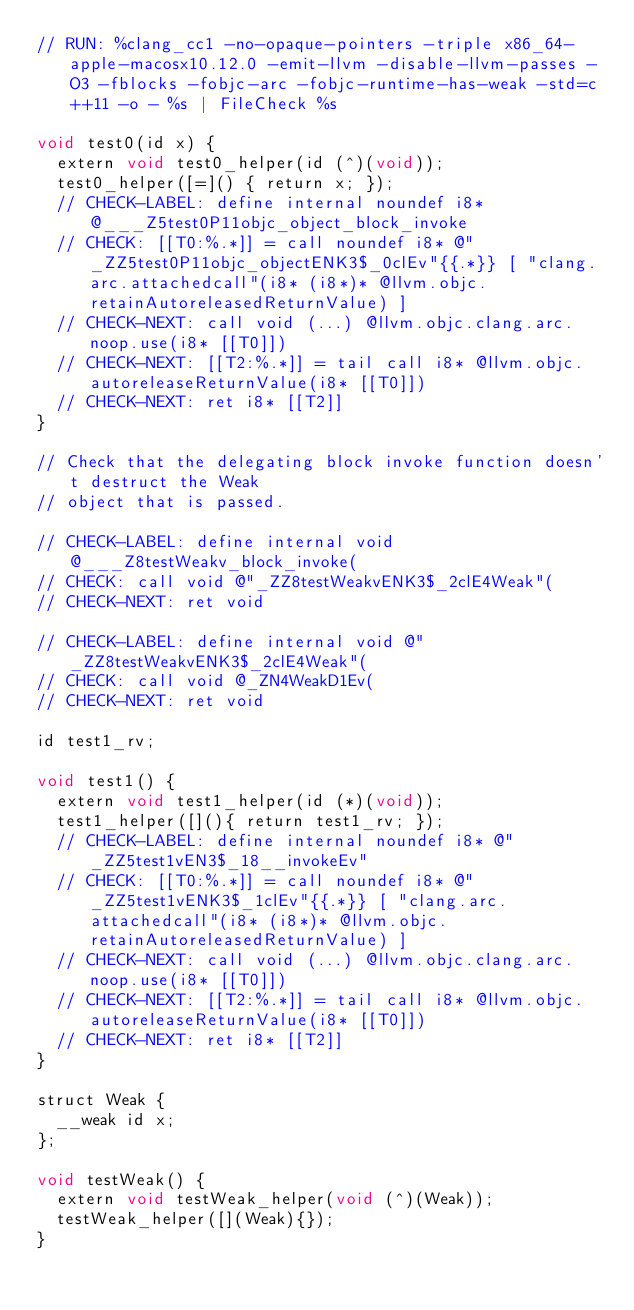Convert code to text. <code><loc_0><loc_0><loc_500><loc_500><_ObjectiveC_>// RUN: %clang_cc1 -no-opaque-pointers -triple x86_64-apple-macosx10.12.0 -emit-llvm -disable-llvm-passes -O3 -fblocks -fobjc-arc -fobjc-runtime-has-weak -std=c++11 -o - %s | FileCheck %s

void test0(id x) {
  extern void test0_helper(id (^)(void));
  test0_helper([=]() { return x; });
  // CHECK-LABEL: define internal noundef i8* @___Z5test0P11objc_object_block_invoke
  // CHECK: [[T0:%.*]] = call noundef i8* @"_ZZ5test0P11objc_objectENK3$_0clEv"{{.*}} [ "clang.arc.attachedcall"(i8* (i8*)* @llvm.objc.retainAutoreleasedReturnValue) ]
  // CHECK-NEXT: call void (...) @llvm.objc.clang.arc.noop.use(i8* [[T0]])
  // CHECK-NEXT: [[T2:%.*]] = tail call i8* @llvm.objc.autoreleaseReturnValue(i8* [[T0]])
  // CHECK-NEXT: ret i8* [[T2]]
}

// Check that the delegating block invoke function doesn't destruct the Weak
// object that is passed.

// CHECK-LABEL: define internal void @___Z8testWeakv_block_invoke(
// CHECK: call void @"_ZZ8testWeakvENK3$_2clE4Weak"(
// CHECK-NEXT: ret void

// CHECK-LABEL: define internal void @"_ZZ8testWeakvENK3$_2clE4Weak"(
// CHECK: call void @_ZN4WeakD1Ev(
// CHECK-NEXT: ret void

id test1_rv;

void test1() {
  extern void test1_helper(id (*)(void));
  test1_helper([](){ return test1_rv; });
  // CHECK-LABEL: define internal noundef i8* @"_ZZ5test1vEN3$_18__invokeEv"
  // CHECK: [[T0:%.*]] = call noundef i8* @"_ZZ5test1vENK3$_1clEv"{{.*}} [ "clang.arc.attachedcall"(i8* (i8*)* @llvm.objc.retainAutoreleasedReturnValue) ]
  // CHECK-NEXT: call void (...) @llvm.objc.clang.arc.noop.use(i8* [[T0]])
  // CHECK-NEXT: [[T2:%.*]] = tail call i8* @llvm.objc.autoreleaseReturnValue(i8* [[T0]])
  // CHECK-NEXT: ret i8* [[T2]]
}

struct Weak {
  __weak id x;
};

void testWeak() {
  extern void testWeak_helper(void (^)(Weak));
  testWeak_helper([](Weak){});
}
</code> 